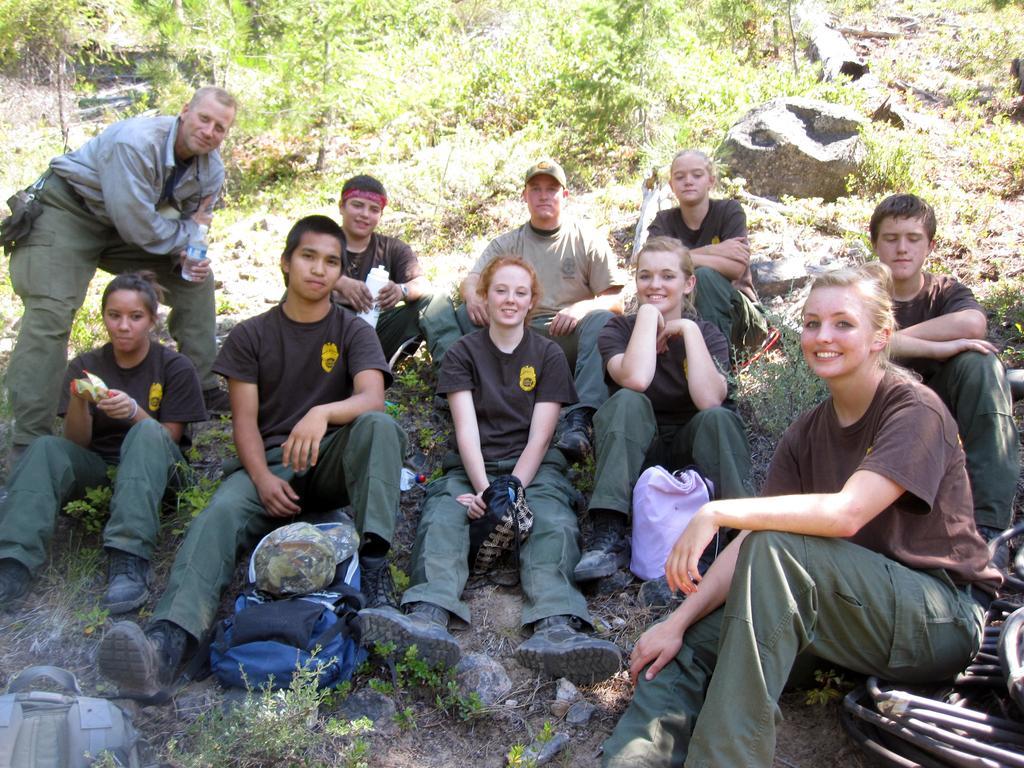Describe this image in one or two sentences. In this picture we can see a cap, bags, bottles, plants and some objects and some people sitting on the ground and smiling and a man standing and in the background we can see trees. 